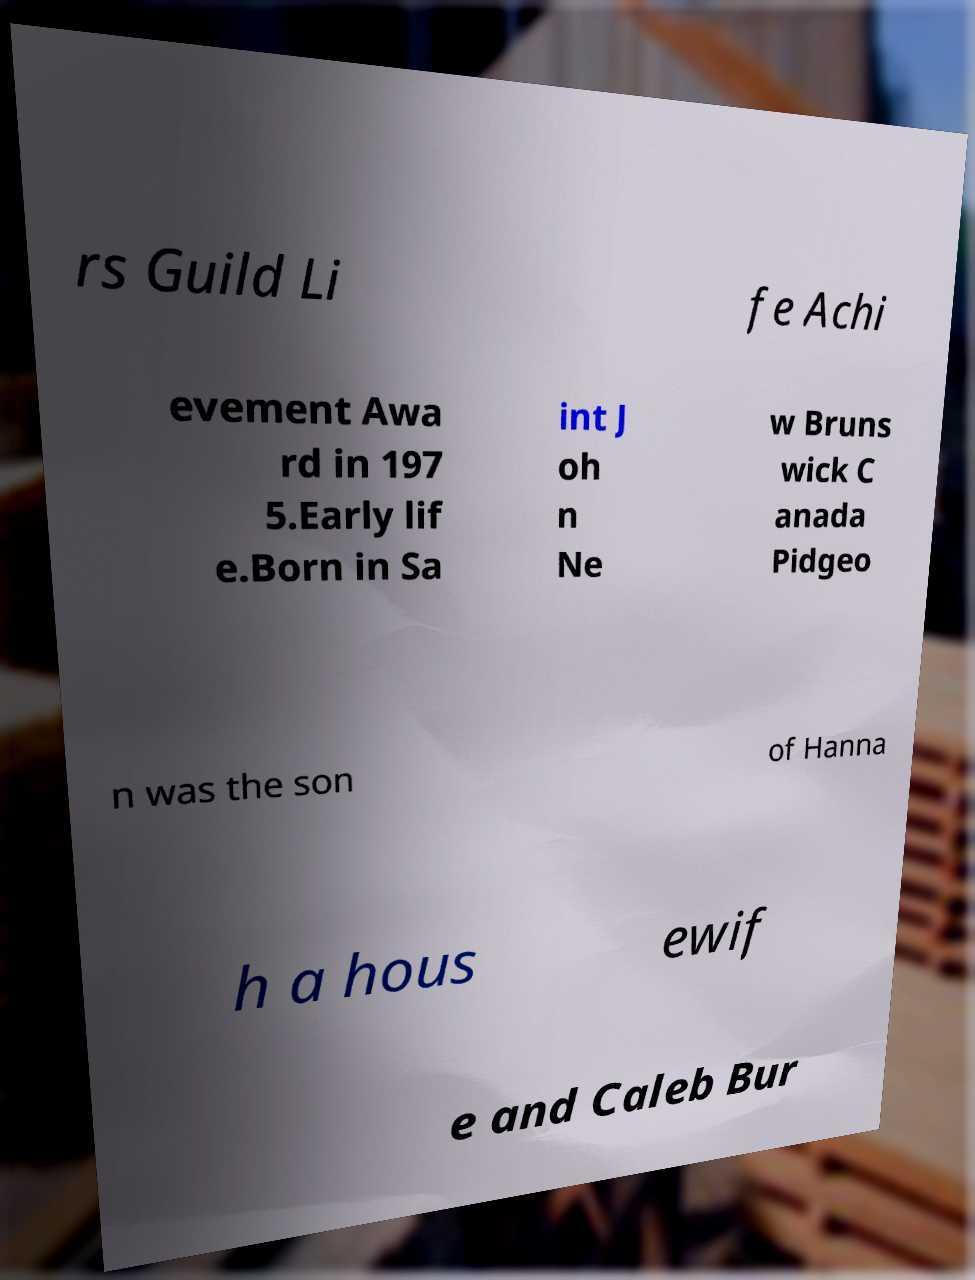What messages or text are displayed in this image? I need them in a readable, typed format. rs Guild Li fe Achi evement Awa rd in 197 5.Early lif e.Born in Sa int J oh n Ne w Bruns wick C anada Pidgeo n was the son of Hanna h a hous ewif e and Caleb Bur 